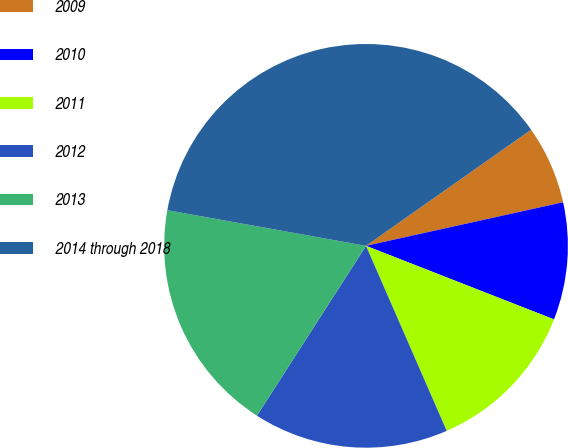<chart> <loc_0><loc_0><loc_500><loc_500><pie_chart><fcel>2009<fcel>2010<fcel>2011<fcel>2012<fcel>2013<fcel>2014 through 2018<nl><fcel>6.29%<fcel>9.4%<fcel>12.52%<fcel>15.63%<fcel>18.74%<fcel>37.42%<nl></chart> 